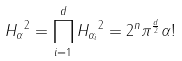Convert formula to latex. <formula><loc_0><loc_0><loc_500><loc_500>\| H _ { \alpha } \| ^ { 2 } = \prod _ { i = 1 } ^ { d } \| H _ { \alpha _ { i } } \| ^ { 2 } = 2 ^ { n } \pi ^ { \frac { d } { 2 } } \alpha !</formula> 